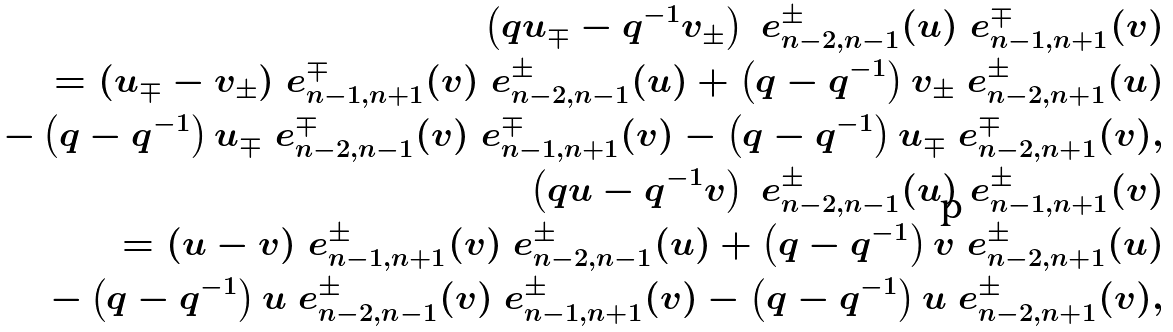<formula> <loc_0><loc_0><loc_500><loc_500>\left ( q u _ { \mp } - q ^ { - 1 } v _ { \pm } \right ) \ e _ { n - 2 , n - 1 } ^ { \pm } ( u ) \ e _ { n - 1 , n + 1 } ^ { \mp } ( v ) \\ = ( u _ { \mp } - v _ { \pm } ) \ e _ { n - 1 , n + 1 } ^ { \mp } ( v ) \ e _ { n - 2 , n - 1 } ^ { \pm } ( u ) + \left ( q - q ^ { - 1 } \right ) v _ { \pm } \ e _ { n - 2 , n + 1 } ^ { \pm } ( u ) \\ \quad - \left ( q - q ^ { - 1 } \right ) u _ { \mp } \ e _ { n - 2 , n - 1 } ^ { \mp } ( v ) \ e _ { n - 1 , n + 1 } ^ { \mp } ( v ) - \left ( q - q ^ { - 1 } \right ) u _ { \mp } \ e _ { n - 2 , n + 1 } ^ { \mp } ( v ) , \\ \left ( q u - q ^ { - 1 } v \right ) \ e _ { n - 2 , n - 1 } ^ { \pm } ( u ) \ e _ { n - 1 , n + 1 } ^ { \pm } ( v ) \\ = ( u - v ) \ e _ { n - 1 , n + 1 } ^ { \pm } ( v ) \ e _ { n - 2 , n - 1 } ^ { \pm } ( u ) + \left ( q - q ^ { - 1 } \right ) v \ e _ { n - 2 , n + 1 } ^ { \pm } ( u ) \\ \quad - \left ( q - q ^ { - 1 } \right ) u \ e _ { n - 2 , n - 1 } ^ { \pm } ( v ) \ e _ { n - 1 , n + 1 } ^ { \pm } ( v ) - \left ( q - q ^ { - 1 } \right ) u \ e _ { n - 2 , n + 1 } ^ { \pm } ( v ) ,</formula> 